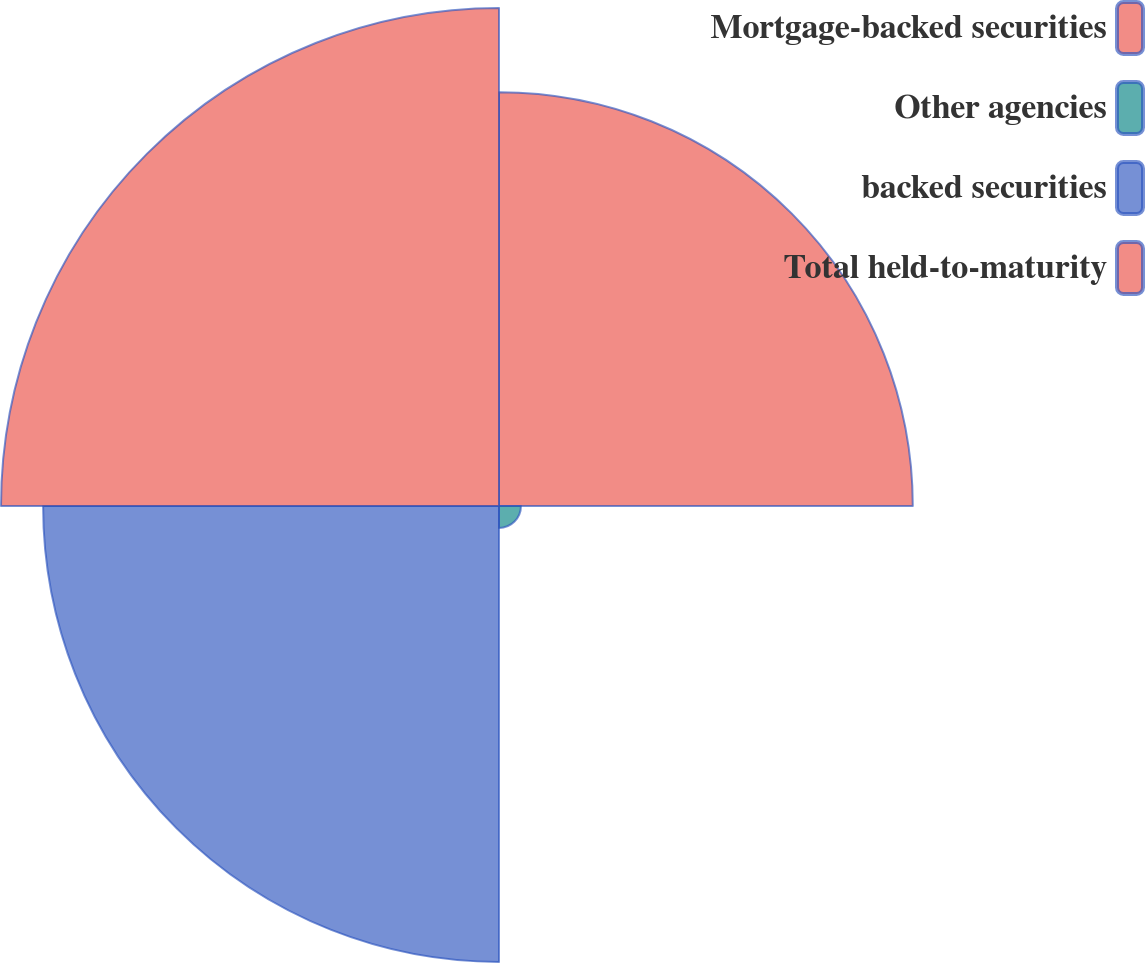Convert chart to OTSL. <chart><loc_0><loc_0><loc_500><loc_500><pie_chart><fcel>Mortgage-backed securities<fcel>Other agencies<fcel>backed securities<fcel>Total held-to-maturity<nl><fcel>29.78%<fcel>1.58%<fcel>32.81%<fcel>35.84%<nl></chart> 